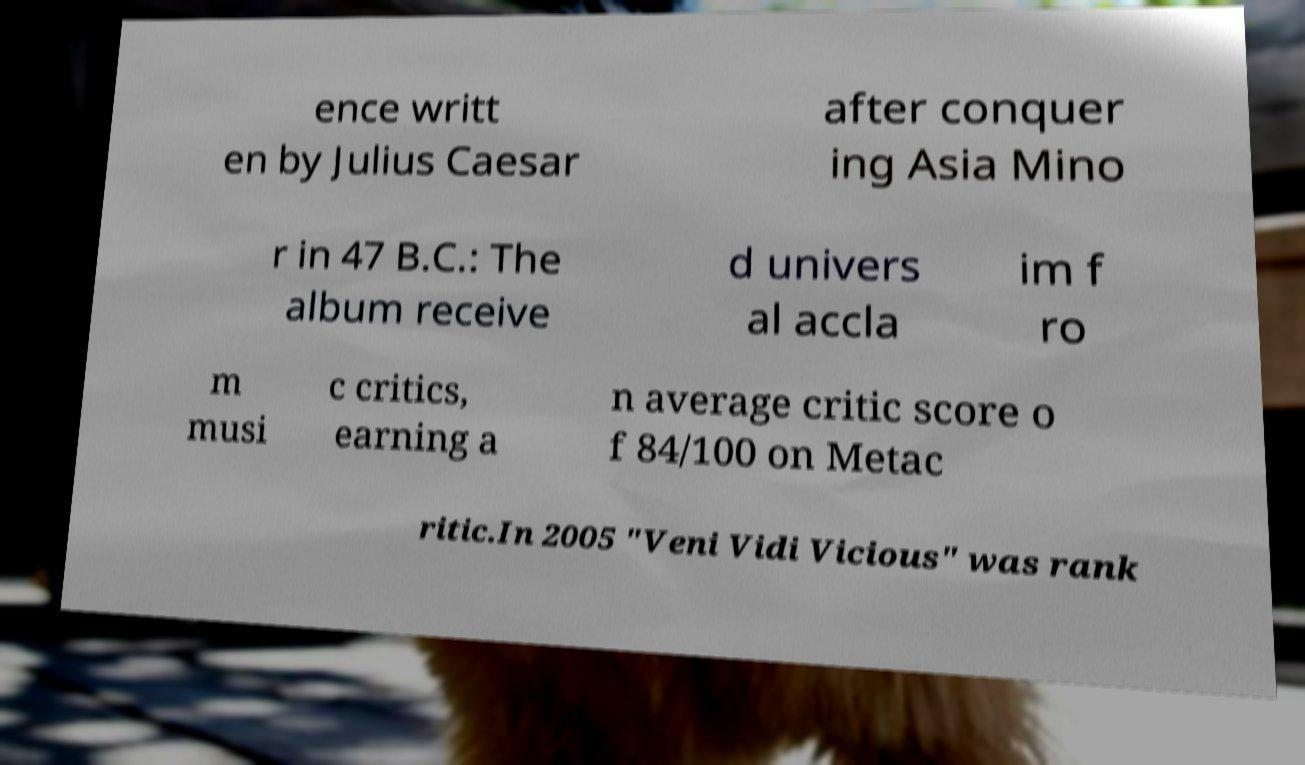There's text embedded in this image that I need extracted. Can you transcribe it verbatim? ence writt en by Julius Caesar after conquer ing Asia Mino r in 47 B.C.: The album receive d univers al accla im f ro m musi c critics, earning a n average critic score o f 84/100 on Metac ritic.In 2005 "Veni Vidi Vicious" was rank 